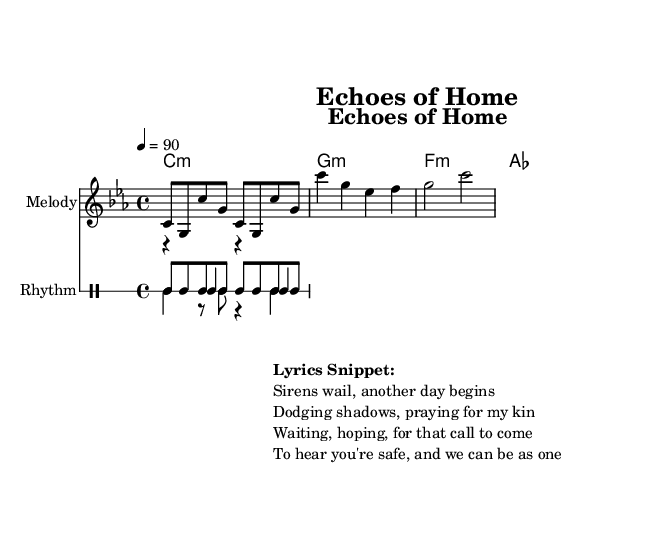What is the key signature of this music? The key signature listed in the global section indicates C minor, which has three flats (B♭, E♭, A♭).
Answer: C minor What is the time signature of the piece? The time signature found in the global section is 4/4, which means there are four beats in each measure and the quarter note gets one beat.
Answer: 4/4 What is the tempo marking of the music? The tempo is indicated as a quarter note equals 90 beats per minute in the global section, which gives the speed of the piece.
Answer: 90 How many measures are in the chorus section? In the melody section, the chorus consists of four measures as delineated by the vertical bar lines.
Answer: 4 Which instruments are indicated in the score? The score includes a melody staff and a drum staff for rhythm, as explicitly stated in the layout of the score.
Answer: Melody and Rhythm What style of music does this piece represent? The lyrics provided reflect themes common in underground rap, such as struggle and hope in conflict zones, indicating this musical style.
Answer: Underground rap What do the lyrics suggest about the emotional state of the narrator? The lyrics express themes of anxiety and longing for safety and connection, reflecting a deep emotional struggle due to the conflict.
Answer: Anxious and hopeful 